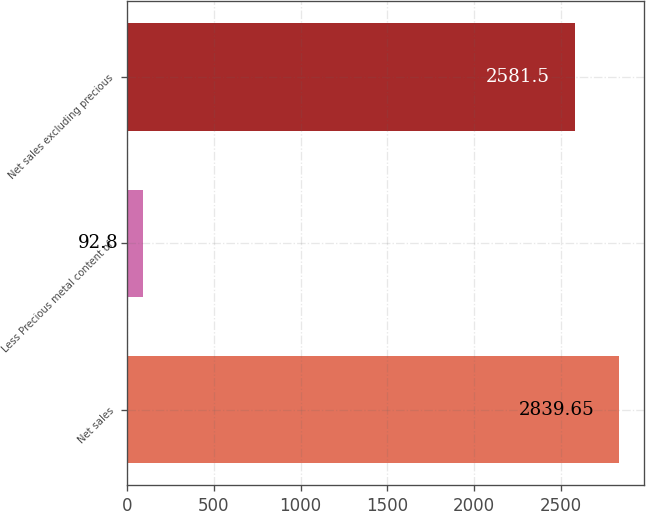<chart> <loc_0><loc_0><loc_500><loc_500><bar_chart><fcel>Net sales<fcel>Less Precious metal content of<fcel>Net sales excluding precious<nl><fcel>2839.65<fcel>92.8<fcel>2581.5<nl></chart> 